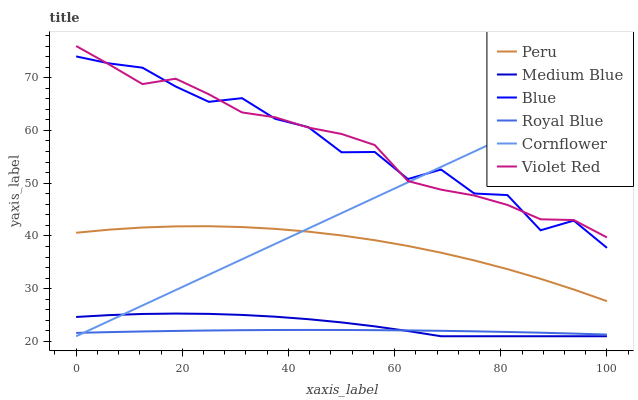Does Royal Blue have the minimum area under the curve?
Answer yes or no. Yes. Does Blue have the maximum area under the curve?
Answer yes or no. Yes. Does Cornflower have the minimum area under the curve?
Answer yes or no. No. Does Cornflower have the maximum area under the curve?
Answer yes or no. No. Is Cornflower the smoothest?
Answer yes or no. Yes. Is Blue the roughest?
Answer yes or no. Yes. Is Violet Red the smoothest?
Answer yes or no. No. Is Violet Red the roughest?
Answer yes or no. No. Does Cornflower have the lowest value?
Answer yes or no. Yes. Does Violet Red have the lowest value?
Answer yes or no. No. Does Violet Red have the highest value?
Answer yes or no. Yes. Does Cornflower have the highest value?
Answer yes or no. No. Is Medium Blue less than Peru?
Answer yes or no. Yes. Is Blue greater than Royal Blue?
Answer yes or no. Yes. Does Blue intersect Violet Red?
Answer yes or no. Yes. Is Blue less than Violet Red?
Answer yes or no. No. Is Blue greater than Violet Red?
Answer yes or no. No. Does Medium Blue intersect Peru?
Answer yes or no. No. 